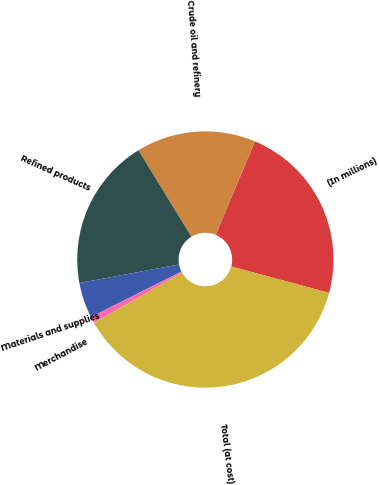<chart> <loc_0><loc_0><loc_500><loc_500><pie_chart><fcel>(In millions)<fcel>Crude oil and refinery<fcel>Refined products<fcel>Materials and supplies<fcel>Merchandise<fcel>Total (at cost)<nl><fcel>22.87%<fcel>15.07%<fcel>19.19%<fcel>4.48%<fcel>0.81%<fcel>37.58%<nl></chart> 